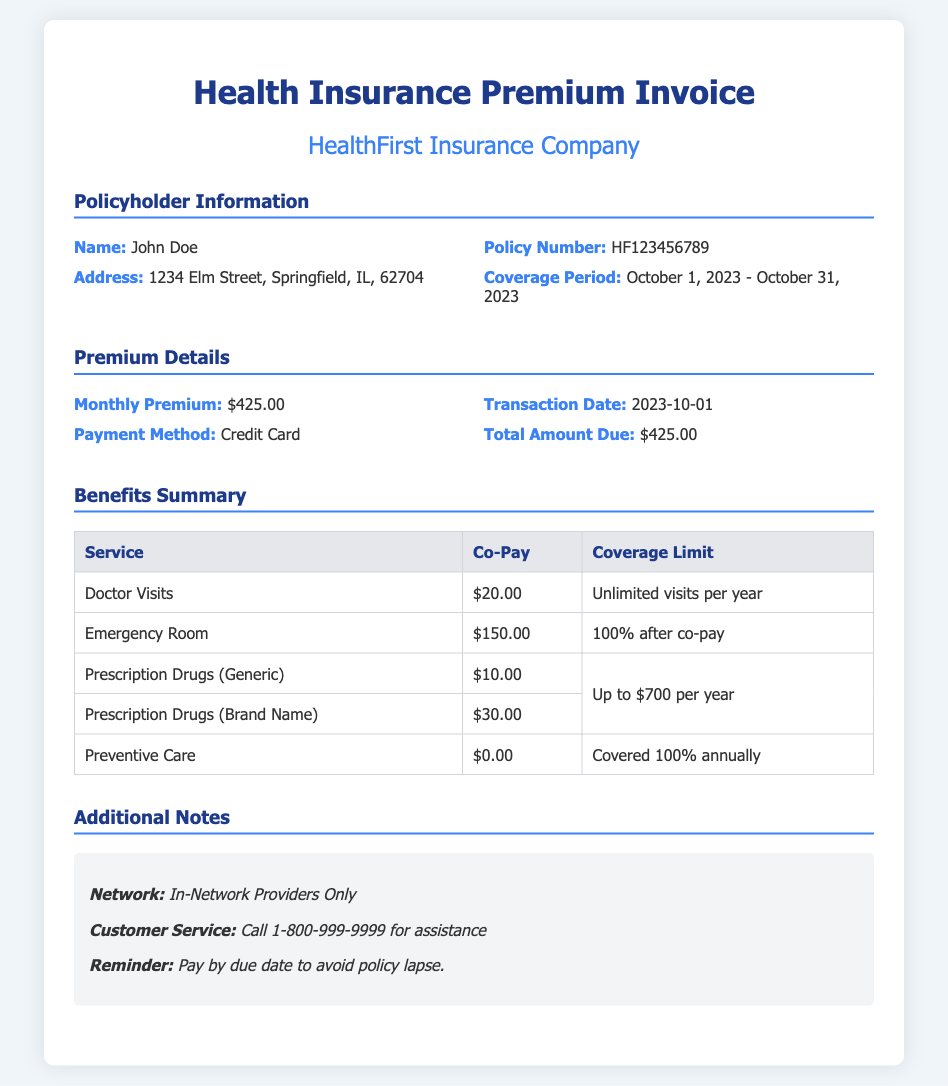what is the name of the policyholder? The policyholder's name is listed in the document under "Policyholder Information."
Answer: John Doe what is the policy number? The policy number can be found in the "Policyholder Information" section of the document.
Answer: HF123456789 what is the monthly premium amount? The monthly premium is specified in the "Premium Details" section of the document.
Answer: $425.00 what is the co-pay for doctor visits? The co-pay for doctor visits is listed in the "Benefits Summary" table under the "Co-Pay" column.
Answer: $20.00 how long is the coverage period? The coverage period is indicated in the "Policyholder Information" section.
Answer: October 1, 2023 - October 31, 2023 what is the total amount due? The total amount due is found in the "Premium Details" section of the document.
Answer: $425.00 what is the co-pay for emergency room visits? The co-pay required for emergency room visits is stated in the "Benefits Summary" table.
Answer: $150.00 how many visits per year are covered for doctor visits? The visits per year for doctor visits can be found in the "Benefits Summary" table.
Answer: Unlimited visits per year what is the customer service phone number? The customer service phone number is provided in the "Additional Notes" section of the document.
Answer: 1-800-999-9999 what is the coverage limit for prescription drugs? The coverage limit for prescription drugs can be gleaned from the "Benefits Summary" table under the corresponding row.
Answer: Up to $700 per year 